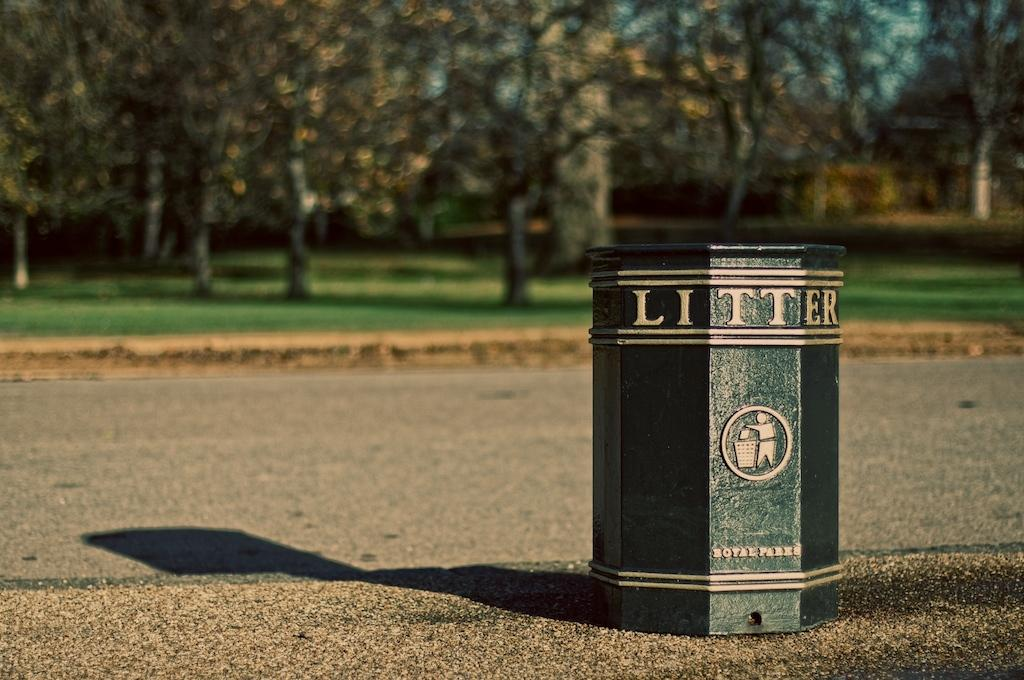<image>
Provide a brief description of the given image. A green trash can with gold letters on the side that says LITTER 